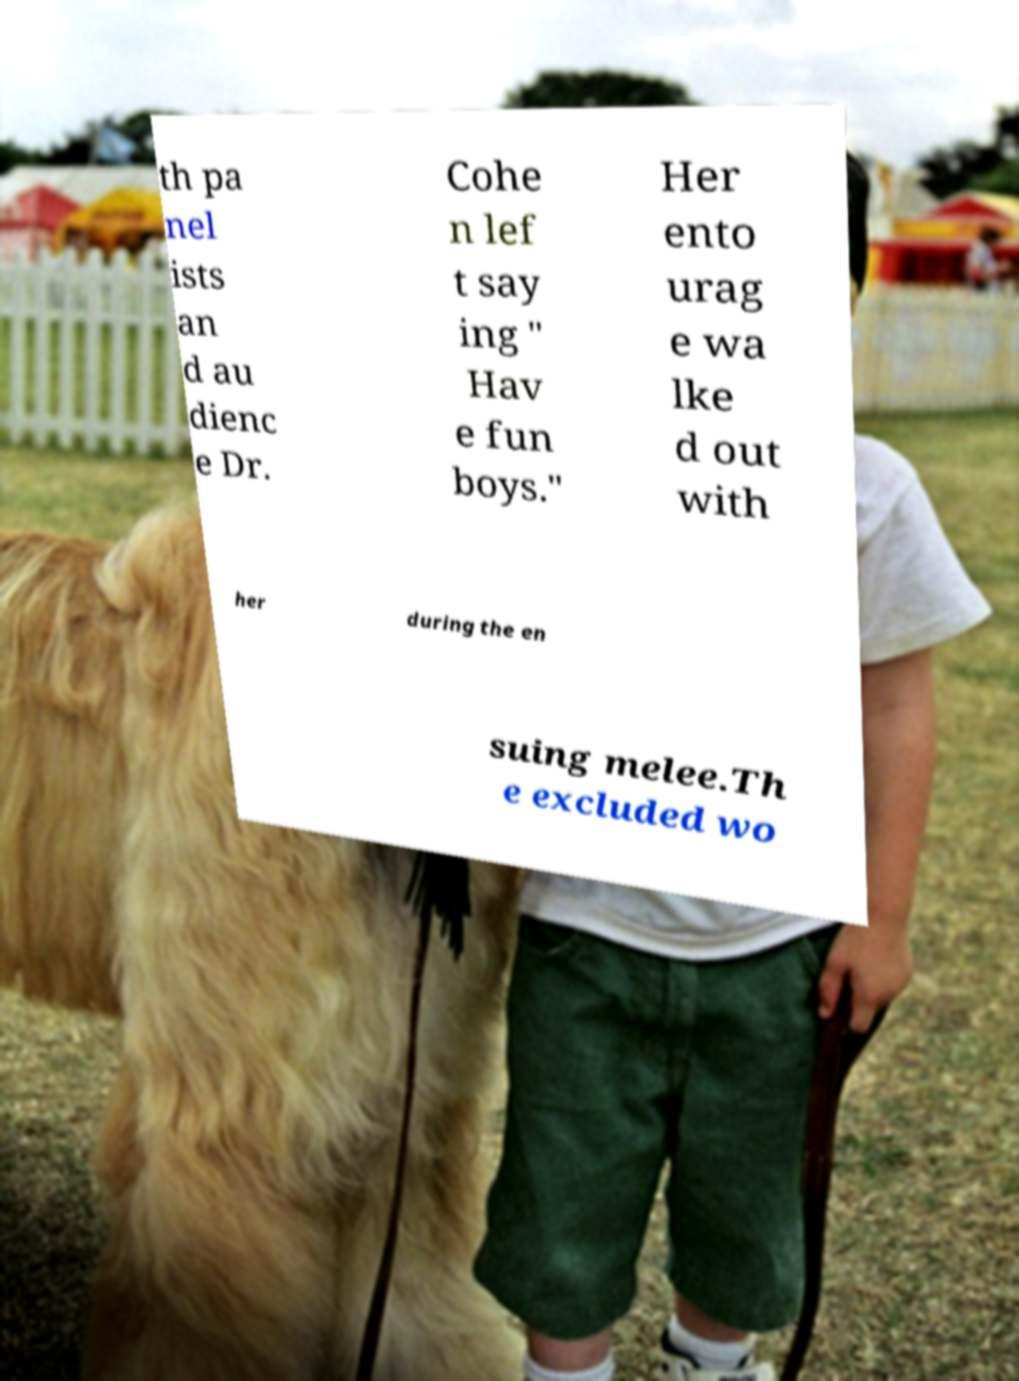I need the written content from this picture converted into text. Can you do that? th pa nel ists an d au dienc e Dr. Cohe n lef t say ing " Hav e fun boys." Her ento urag e wa lke d out with her during the en suing melee.Th e excluded wo 